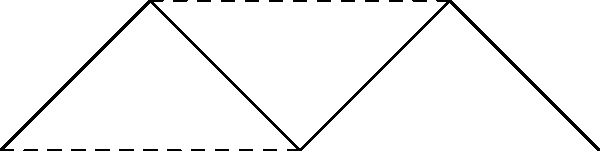In the context of using graph matching algorithms to align different demographic subgroups in AI training datasets, consider the graph above representing two subgroups (A and B) with nodes $G_1$ to $G_5$. Each node represents a set of data points from a specific demographic. The solid lines represent strong similarities, while dashed lines represent weaker similarities. What graph matching algorithm would be most appropriate to align these subgroups while ensuring fair representation, and what potential bias might this approach introduce? To answer this question, let's consider the following steps:

1. Analyze the graph structure:
   - We have two subgroups (A and B) with 5 nodes total.
   - Solid lines indicate strong similarities, dashed lines indicate weaker similarities.
   - There are connections both within and between subgroups.

2. Consider appropriate graph matching algorithms:
   - Maximum Weighted Matching (MWM) could be used, assigning higher weights to solid lines.
   - Bipartite Matching could be applied by treating the two subgroups as separate sets.

3. Evaluate the most appropriate algorithm:
   - Given the structure and the need for fair representation, the Hungarian algorithm (a type of MWM) would be most appropriate.
   - It can handle weighted edges and find an optimal matching that maximizes overall similarity while considering both strong and weak connections.

4. Application of the Hungarian algorithm:
   - Assign higher weights to solid lines (e.g., 2) and lower weights to dashed lines (e.g., 1).
   - The algorithm will find the maximum weight matching, aligning the most similar data points across subgroups.

5. Potential bias introduction:
   - Over-emphasis on strong similarities might lead to underrepresentation of unique characteristics in each subgroup.
   - The algorithm might favor matching based on majority group characteristics if they are more strongly connected.

6. Mitigation strategies:
   - Carefully calibrate edge weights to balance strong and weak similarities.
   - Implement constraints to ensure a minimum number of matches for each node, guaranteeing representation of all demographics.
   - Post-process the results to ensure fair representation of minority groups.
Answer: Hungarian algorithm; potential bias towards majority group characteristics 